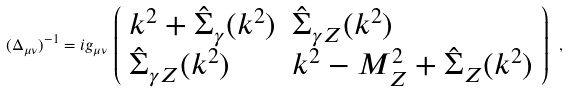<formula> <loc_0><loc_0><loc_500><loc_500>( \Delta _ { \mu \nu } ) ^ { - 1 } = i g _ { \mu \nu } \, \left ( \begin{array} { l l } k ^ { 2 } + \hat { \Sigma } _ { \gamma } ( k ^ { 2 } ) & \hat { \Sigma } _ { \gamma Z } ( k ^ { 2 } ) \\ \hat { \Sigma } _ { \gamma Z } ( k ^ { 2 } ) & k ^ { 2 } - M _ { Z } ^ { 2 } + \hat { \Sigma } _ { Z } ( k ^ { 2 } ) \end{array} \right ) \ ,</formula> 